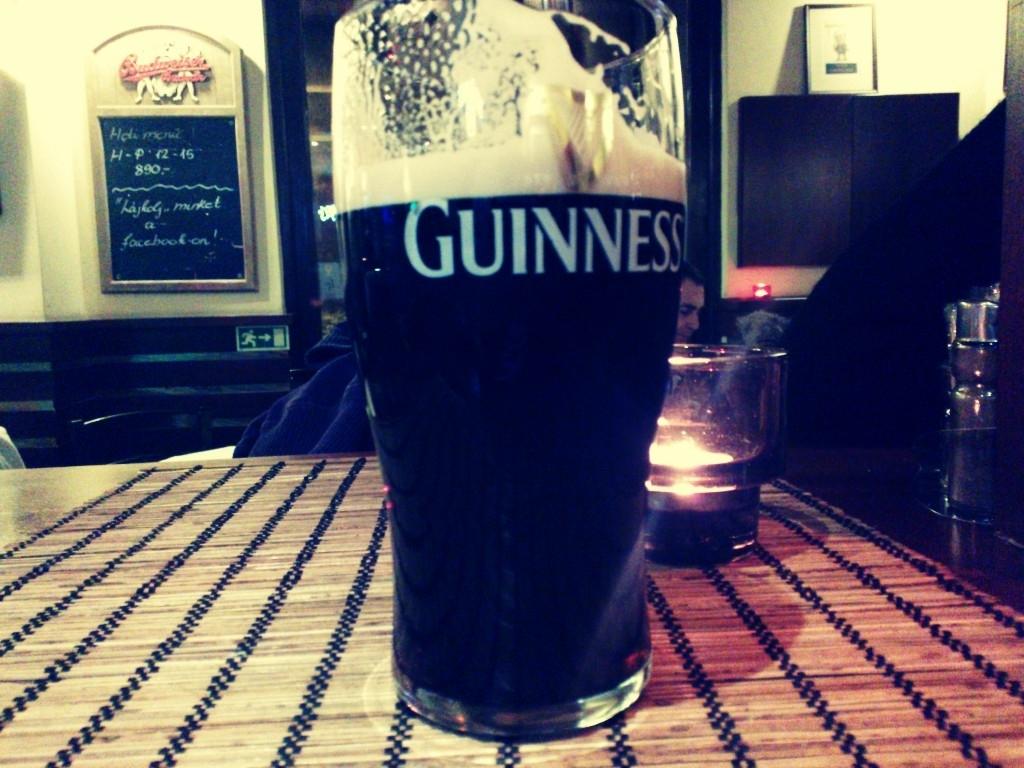Who made this glass?
Provide a short and direct response. Guinness. What number is written under h-p?
Offer a terse response. 890. 